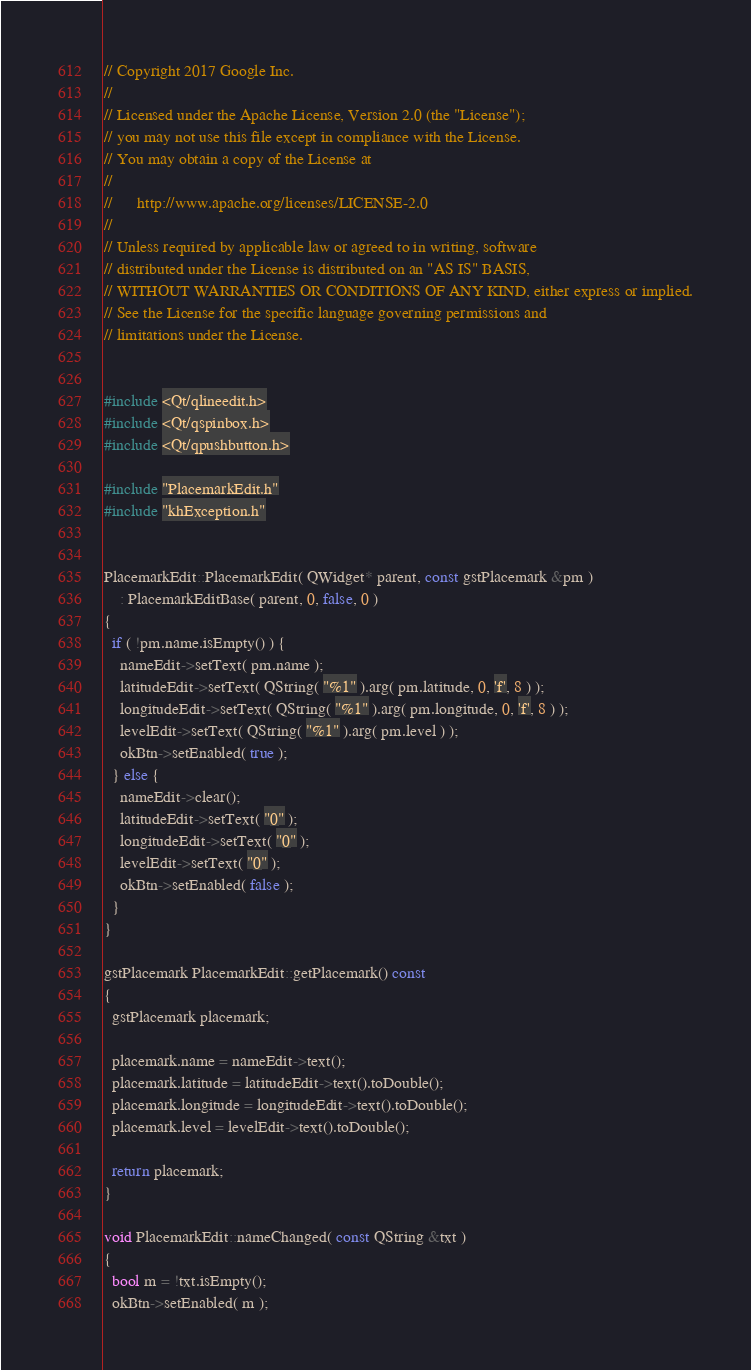<code> <loc_0><loc_0><loc_500><loc_500><_C++_>// Copyright 2017 Google Inc.
//
// Licensed under the Apache License, Version 2.0 (the "License");
// you may not use this file except in compliance with the License.
// You may obtain a copy of the License at
//
//      http://www.apache.org/licenses/LICENSE-2.0
//
// Unless required by applicable law or agreed to in writing, software
// distributed under the License is distributed on an "AS IS" BASIS,
// WITHOUT WARRANTIES OR CONDITIONS OF ANY KIND, either express or implied.
// See the License for the specific language governing permissions and
// limitations under the License.


#include <Qt/qlineedit.h>
#include <Qt/qspinbox.h>
#include <Qt/qpushbutton.h>

#include "PlacemarkEdit.h"
#include "khException.h"


PlacemarkEdit::PlacemarkEdit( QWidget* parent, const gstPlacemark &pm )
    : PlacemarkEditBase( parent, 0, false, 0 )
{
  if ( !pm.name.isEmpty() ) {
    nameEdit->setText( pm.name );
    latitudeEdit->setText( QString( "%1" ).arg( pm.latitude, 0, 'f', 8 ) );
    longitudeEdit->setText( QString( "%1" ).arg( pm.longitude, 0, 'f', 8 ) );
    levelEdit->setText( QString( "%1" ).arg( pm.level ) );
    okBtn->setEnabled( true );
  } else {
    nameEdit->clear();
    latitudeEdit->setText( "0" );
    longitudeEdit->setText( "0" );
    levelEdit->setText( "0" );
    okBtn->setEnabled( false );
  }
}

gstPlacemark PlacemarkEdit::getPlacemark() const
{
  gstPlacemark placemark;

  placemark.name = nameEdit->text();
  placemark.latitude = latitudeEdit->text().toDouble();
  placemark.longitude = longitudeEdit->text().toDouble();
  placemark.level = levelEdit->text().toDouble();

  return placemark;
}

void PlacemarkEdit::nameChanged( const QString &txt )
{
  bool m = !txt.isEmpty();
  okBtn->setEnabled( m );</code> 